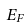<formula> <loc_0><loc_0><loc_500><loc_500>E _ { F }</formula> 